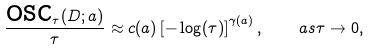Convert formula to latex. <formula><loc_0><loc_0><loc_500><loc_500>\frac { \text {osc} _ { \tau } ( D ; a ) } { \tau } \approx c ( a ) \left [ - \log ( \tau ) \right ] ^ { \gamma ( a ) } , \quad a s \tau \to 0 ,</formula> 